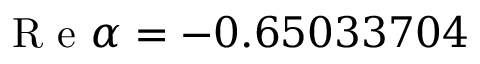<formula> <loc_0><loc_0><loc_500><loc_500>R e \alpha = - 0 . 6 5 0 3 3 7 0 4</formula> 